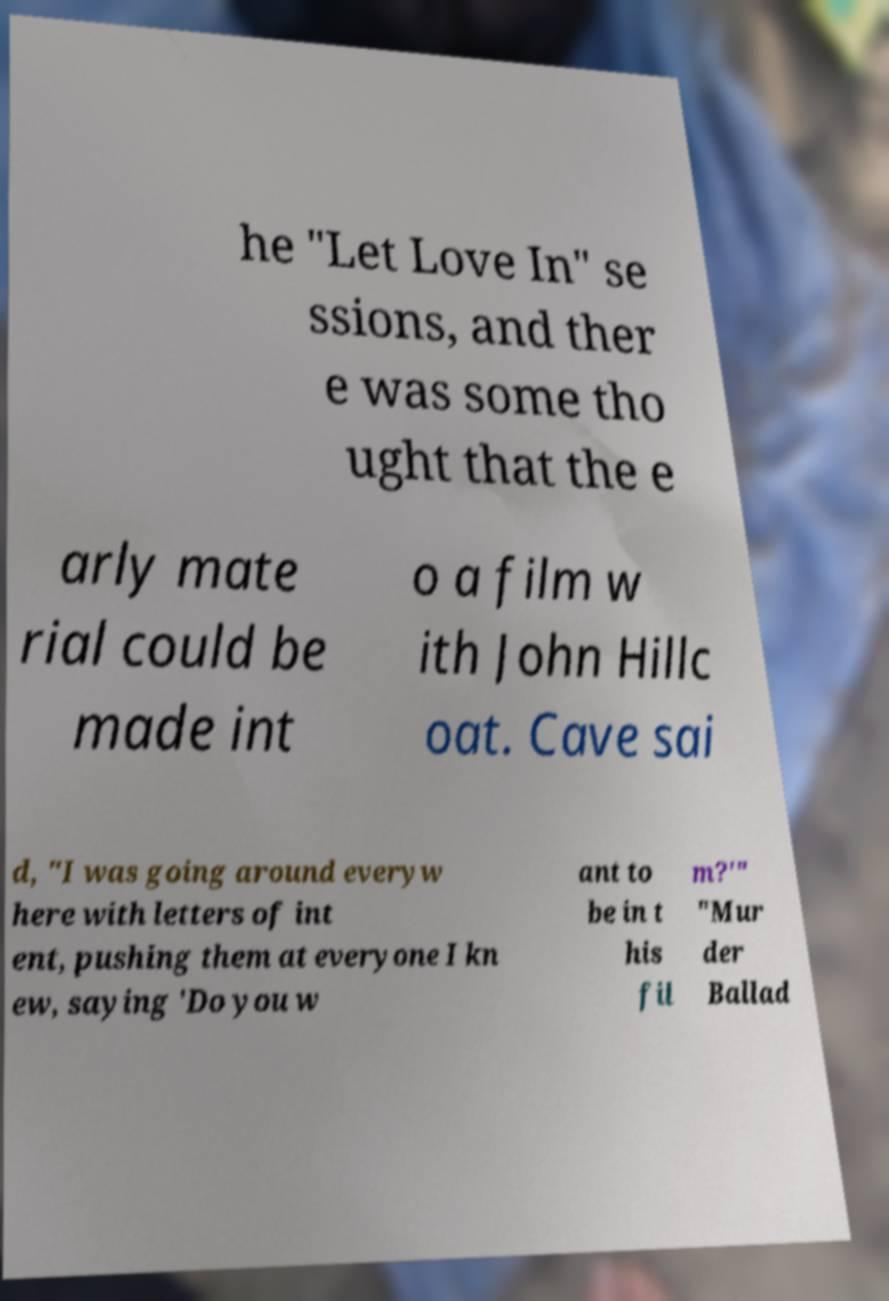Please read and relay the text visible in this image. What does it say? he "Let Love In" se ssions, and ther e was some tho ught that the e arly mate rial could be made int o a film w ith John Hillc oat. Cave sai d, "I was going around everyw here with letters of int ent, pushing them at everyone I kn ew, saying 'Do you w ant to be in t his fil m?'" "Mur der Ballad 